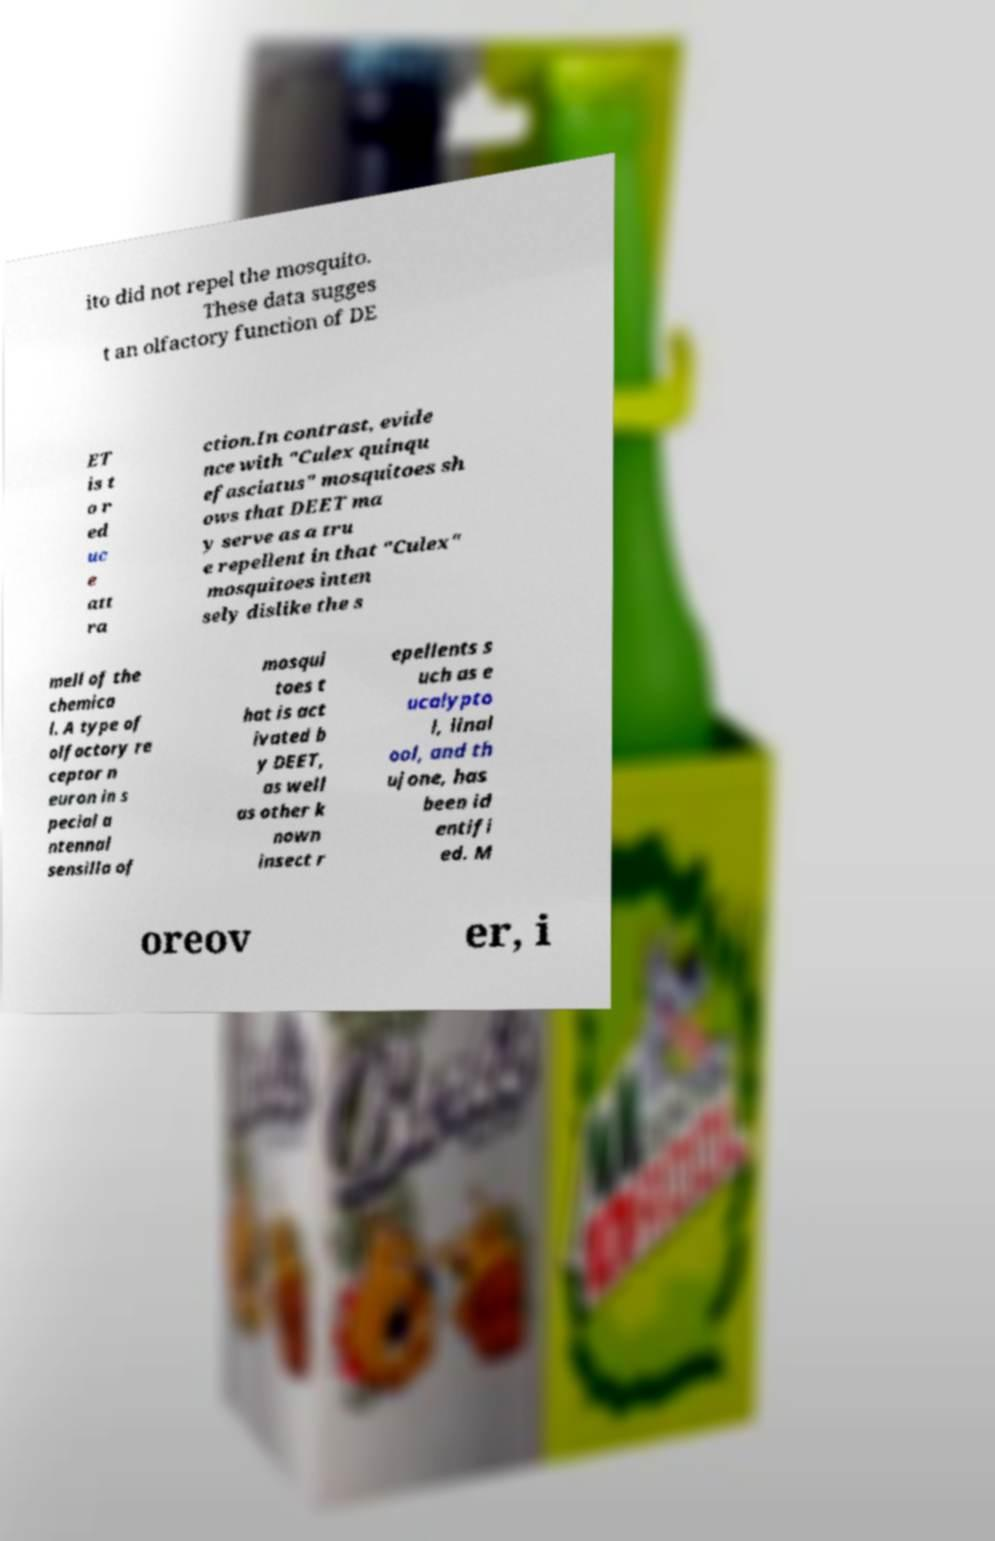Please identify and transcribe the text found in this image. ito did not repel the mosquito. These data sugges t an olfactory function of DE ET is t o r ed uc e att ra ction.In contrast, evide nce with "Culex quinqu efasciatus" mosquitoes sh ows that DEET ma y serve as a tru e repellent in that "Culex" mosquitoes inten sely dislike the s mell of the chemica l. A type of olfactory re ceptor n euron in s pecial a ntennal sensilla of mosqui toes t hat is act ivated b y DEET, as well as other k nown insect r epellents s uch as e ucalypto l, linal ool, and th ujone, has been id entifi ed. M oreov er, i 